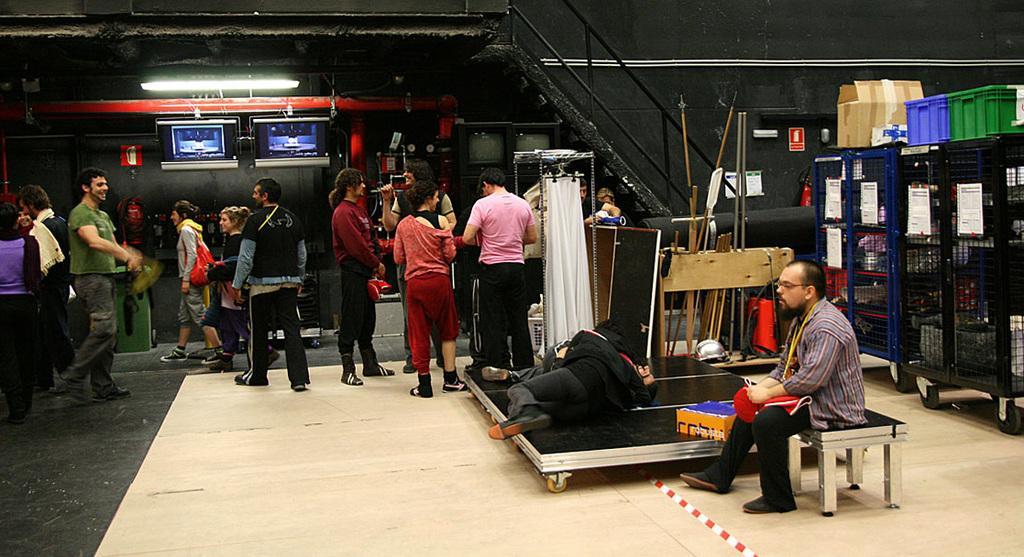In one or two sentences, can you explain what this image depicts? In this picture there are group of people those who are standing on the left side of the image and there are two people those who are lying in the center of the image on a board, there is staircase in the center of the image and there are two televisions on the left side of the image, there are cracks on the right side of the image. 